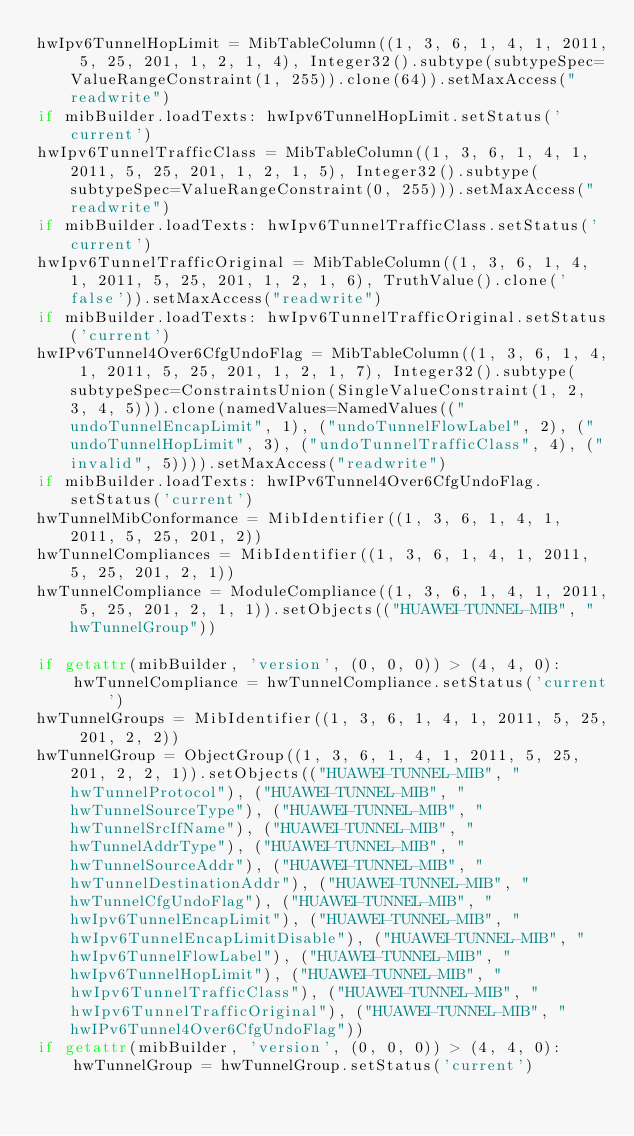<code> <loc_0><loc_0><loc_500><loc_500><_Python_>hwIpv6TunnelHopLimit = MibTableColumn((1, 3, 6, 1, 4, 1, 2011, 5, 25, 201, 1, 2, 1, 4), Integer32().subtype(subtypeSpec=ValueRangeConstraint(1, 255)).clone(64)).setMaxAccess("readwrite")
if mibBuilder.loadTexts: hwIpv6TunnelHopLimit.setStatus('current')
hwIpv6TunnelTrafficClass = MibTableColumn((1, 3, 6, 1, 4, 1, 2011, 5, 25, 201, 1, 2, 1, 5), Integer32().subtype(subtypeSpec=ValueRangeConstraint(0, 255))).setMaxAccess("readwrite")
if mibBuilder.loadTexts: hwIpv6TunnelTrafficClass.setStatus('current')
hwIpv6TunnelTrafficOriginal = MibTableColumn((1, 3, 6, 1, 4, 1, 2011, 5, 25, 201, 1, 2, 1, 6), TruthValue().clone('false')).setMaxAccess("readwrite")
if mibBuilder.loadTexts: hwIpv6TunnelTrafficOriginal.setStatus('current')
hwIPv6Tunnel4Over6CfgUndoFlag = MibTableColumn((1, 3, 6, 1, 4, 1, 2011, 5, 25, 201, 1, 2, 1, 7), Integer32().subtype(subtypeSpec=ConstraintsUnion(SingleValueConstraint(1, 2, 3, 4, 5))).clone(namedValues=NamedValues(("undoTunnelEncapLimit", 1), ("undoTunnelFlowLabel", 2), ("undoTunnelHopLimit", 3), ("undoTunnelTrafficClass", 4), ("invalid", 5)))).setMaxAccess("readwrite")
if mibBuilder.loadTexts: hwIPv6Tunnel4Over6CfgUndoFlag.setStatus('current')
hwTunnelMibConformance = MibIdentifier((1, 3, 6, 1, 4, 1, 2011, 5, 25, 201, 2))
hwTunnelCompliances = MibIdentifier((1, 3, 6, 1, 4, 1, 2011, 5, 25, 201, 2, 1))
hwTunnelCompliance = ModuleCompliance((1, 3, 6, 1, 4, 1, 2011, 5, 25, 201, 2, 1, 1)).setObjects(("HUAWEI-TUNNEL-MIB", "hwTunnelGroup"))

if getattr(mibBuilder, 'version', (0, 0, 0)) > (4, 4, 0):
    hwTunnelCompliance = hwTunnelCompliance.setStatus('current')
hwTunnelGroups = MibIdentifier((1, 3, 6, 1, 4, 1, 2011, 5, 25, 201, 2, 2))
hwTunnelGroup = ObjectGroup((1, 3, 6, 1, 4, 1, 2011, 5, 25, 201, 2, 2, 1)).setObjects(("HUAWEI-TUNNEL-MIB", "hwTunnelProtocol"), ("HUAWEI-TUNNEL-MIB", "hwTunnelSourceType"), ("HUAWEI-TUNNEL-MIB", "hwTunnelSrcIfName"), ("HUAWEI-TUNNEL-MIB", "hwTunnelAddrType"), ("HUAWEI-TUNNEL-MIB", "hwTunnelSourceAddr"), ("HUAWEI-TUNNEL-MIB", "hwTunnelDestinationAddr"), ("HUAWEI-TUNNEL-MIB", "hwTunnelCfgUndoFlag"), ("HUAWEI-TUNNEL-MIB", "hwIpv6TunnelEncapLimit"), ("HUAWEI-TUNNEL-MIB", "hwIpv6TunnelEncapLimitDisable"), ("HUAWEI-TUNNEL-MIB", "hwIpv6TunnelFlowLabel"), ("HUAWEI-TUNNEL-MIB", "hwIpv6TunnelHopLimit"), ("HUAWEI-TUNNEL-MIB", "hwIpv6TunnelTrafficClass"), ("HUAWEI-TUNNEL-MIB", "hwIpv6TunnelTrafficOriginal"), ("HUAWEI-TUNNEL-MIB", "hwIPv6Tunnel4Over6CfgUndoFlag"))
if getattr(mibBuilder, 'version', (0, 0, 0)) > (4, 4, 0):
    hwTunnelGroup = hwTunnelGroup.setStatus('current')</code> 